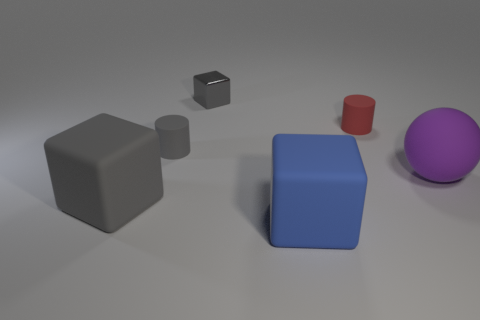Subtract 1 cylinders. How many cylinders are left? 1 Subtract all large matte cubes. How many cubes are left? 1 Add 2 big spheres. How many objects exist? 8 Subtract all blue cubes. How many cubes are left? 2 Subtract 1 blue cubes. How many objects are left? 5 Subtract all cylinders. How many objects are left? 4 Subtract all red cubes. Subtract all brown cylinders. How many cubes are left? 3 Subtract all blue cylinders. How many gray blocks are left? 2 Subtract all large blue cubes. Subtract all brown objects. How many objects are left? 5 Add 3 large purple things. How many large purple things are left? 4 